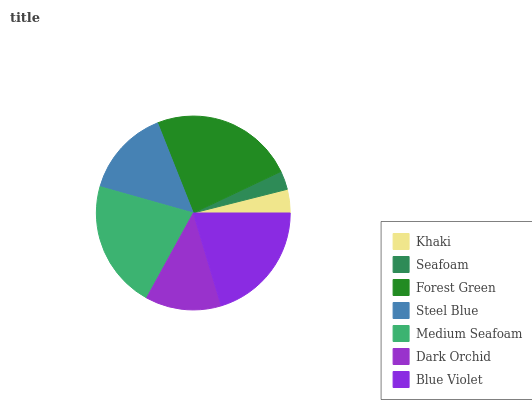Is Seafoam the minimum?
Answer yes or no. Yes. Is Forest Green the maximum?
Answer yes or no. Yes. Is Forest Green the minimum?
Answer yes or no. No. Is Seafoam the maximum?
Answer yes or no. No. Is Forest Green greater than Seafoam?
Answer yes or no. Yes. Is Seafoam less than Forest Green?
Answer yes or no. Yes. Is Seafoam greater than Forest Green?
Answer yes or no. No. Is Forest Green less than Seafoam?
Answer yes or no. No. Is Steel Blue the high median?
Answer yes or no. Yes. Is Steel Blue the low median?
Answer yes or no. Yes. Is Khaki the high median?
Answer yes or no. No. Is Dark Orchid the low median?
Answer yes or no. No. 